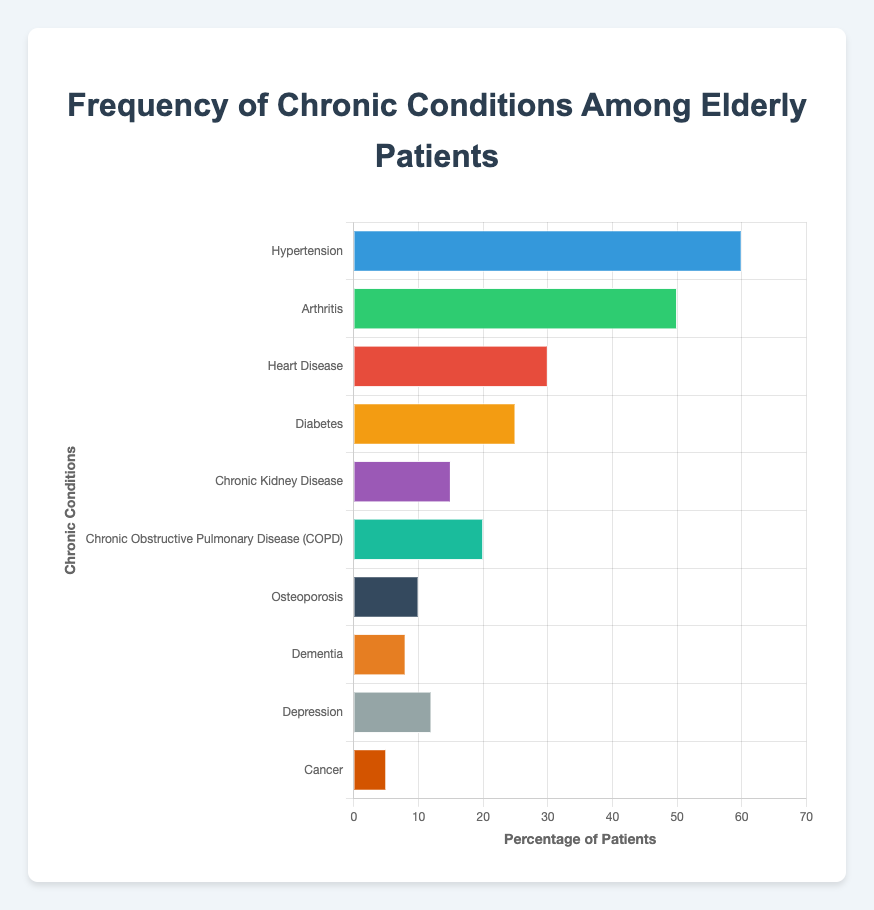What's the most common chronic condition among elderly patients? The most common chronic condition has the highest percentage bar in the chart. Hypertension has a bar with 60%, which is higher than any other condition.
Answer: Hypertension Which condition has the lowest frequency among elderly patients? The condition with the lowest frequency is represented by the shortest bar. Cancer has the shortest bar with 5%.
Answer: Cancer How many more people have Arthritis compared to those with Osteoporosis? Find the percentage of people with Arthritis (50%) and Osteoporosis (10%), then subtract the percentage of Osteoporosis from Arthritis: 50% - 10% = 40%.
Answer: 40% What is the combined percentage of patients with Diabetes and Chronic Kidney Disease? Add the percentage of patients with Diabetes (25%) to the percentage of those with Chronic Kidney Disease (15%): 25% + 15% = 40%.
Answer: 40% Which condition affects fewer patients: Dementia or Depression? Compare the bars for Dementia (8%) and Depression (12%). Dementia has a shorter bar indicating a lower percentage.
Answer: Dementia Which condition has a visual representation in a greenish color? Scan the bars for a greenish color. Arthritis is represented by a greenish color bar at 50%.
Answer: Arthritis By how much does the frequency of patients with COPD exceed that of those with Osteoporosis? Determine the percentage of patients with COPD (20%) and Osteoporosis (10%), then subtract the percentage of Osteoporosis from COPD: 20% - 10% = 10%.
Answer: 10% If you combine the frequencies of Hypertension and Cancer, what percentage of the total patients would it represent? Add the percentages of Hypertension (60%) and Cancer (5%): 60% + 5% = 65%.
Answer: 65% Which two conditions combined have a frequency close to the Hypertension frequency? Compare the sum frequencies of different conditions to find a pair close to 60%. Diabetes (25%) and Heart Disease (30%) combined give: 25% + 30% = 55%, which is close to 60%.
Answer: Diabetes and Heart Disease 